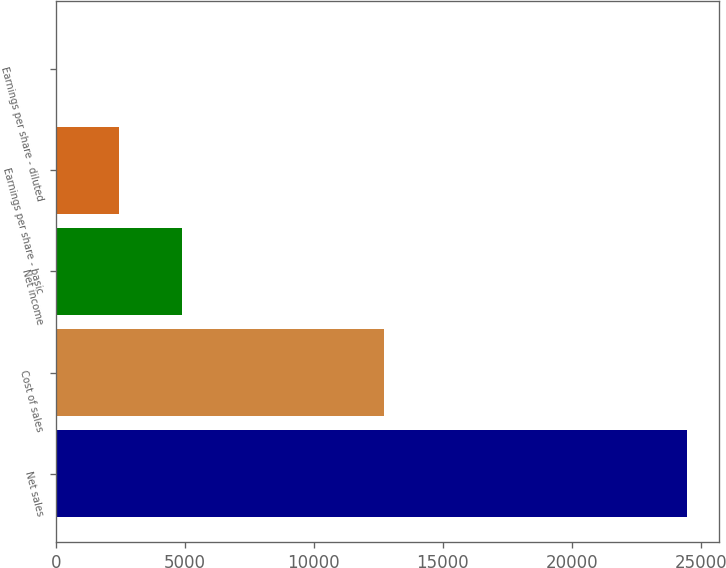Convert chart to OTSL. <chart><loc_0><loc_0><loc_500><loc_500><bar_chart><fcel>Net sales<fcel>Cost of sales<fcel>Net income<fcel>Earnings per share - basic<fcel>Earnings per share - diluted<nl><fcel>24462<fcel>12735<fcel>4896.88<fcel>2451.24<fcel>5.6<nl></chart> 